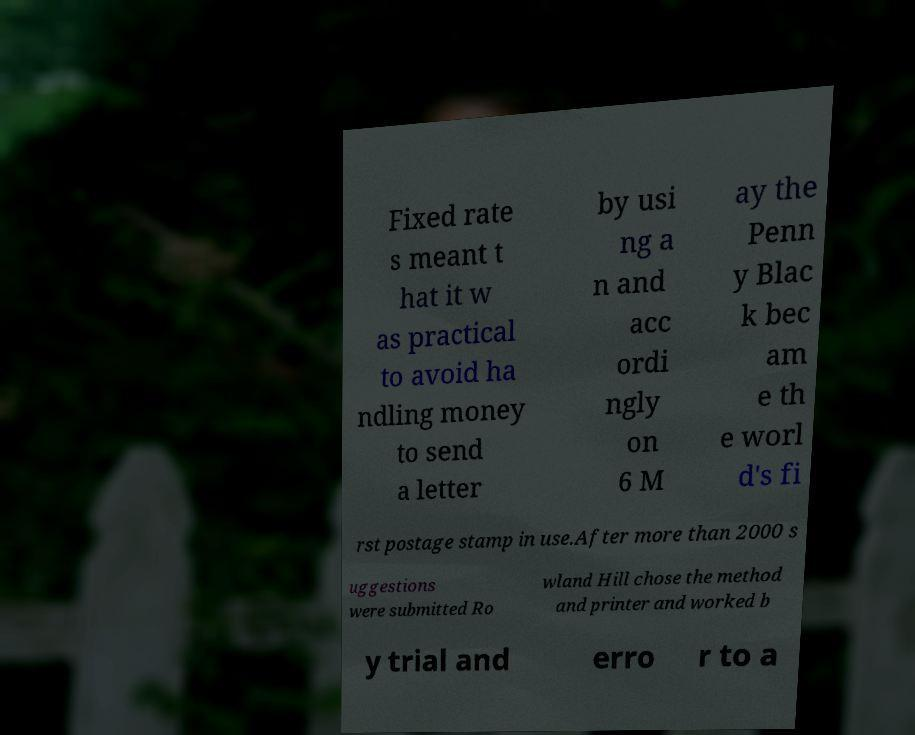Can you read and provide the text displayed in the image?This photo seems to have some interesting text. Can you extract and type it out for me? Fixed rate s meant t hat it w as practical to avoid ha ndling money to send a letter by usi ng a n and acc ordi ngly on 6 M ay the Penn y Blac k bec am e th e worl d's fi rst postage stamp in use.After more than 2000 s uggestions were submitted Ro wland Hill chose the method and printer and worked b y trial and erro r to a 